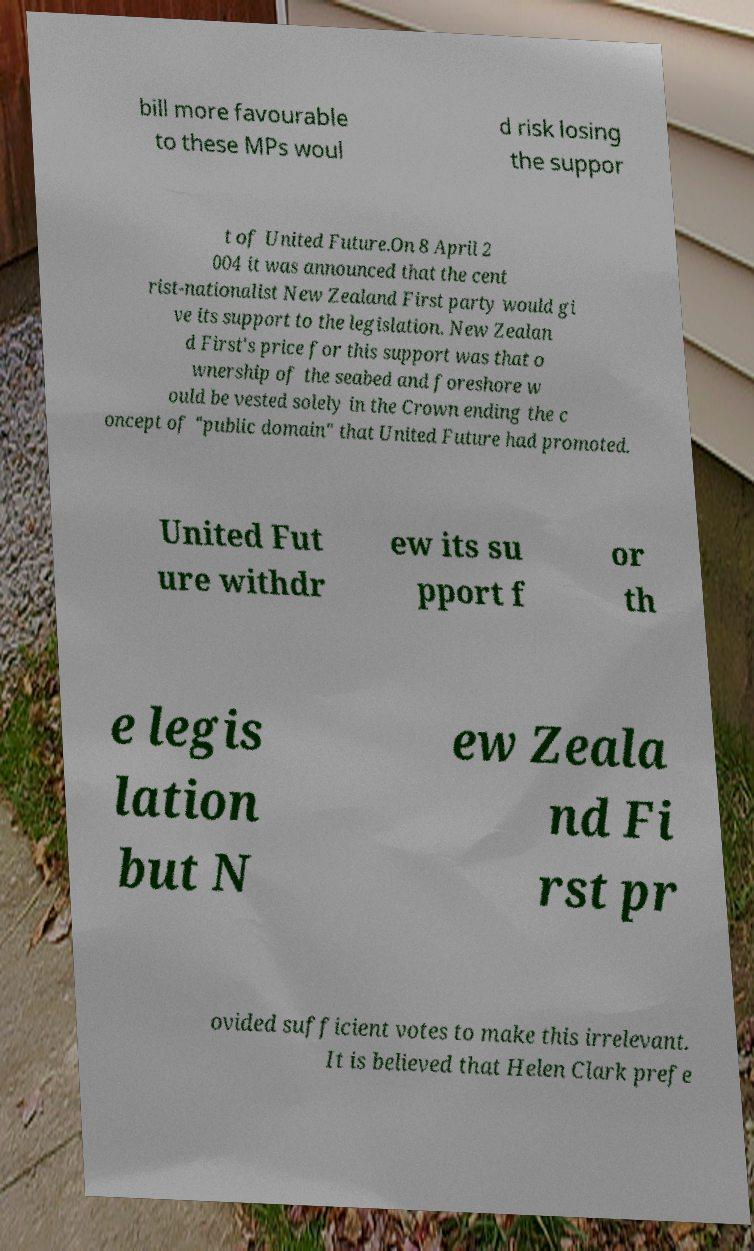Please identify and transcribe the text found in this image. bill more favourable to these MPs woul d risk losing the suppor t of United Future.On 8 April 2 004 it was announced that the cent rist-nationalist New Zealand First party would gi ve its support to the legislation. New Zealan d First's price for this support was that o wnership of the seabed and foreshore w ould be vested solely in the Crown ending the c oncept of "public domain" that United Future had promoted. United Fut ure withdr ew its su pport f or th e legis lation but N ew Zeala nd Fi rst pr ovided sufficient votes to make this irrelevant. It is believed that Helen Clark prefe 